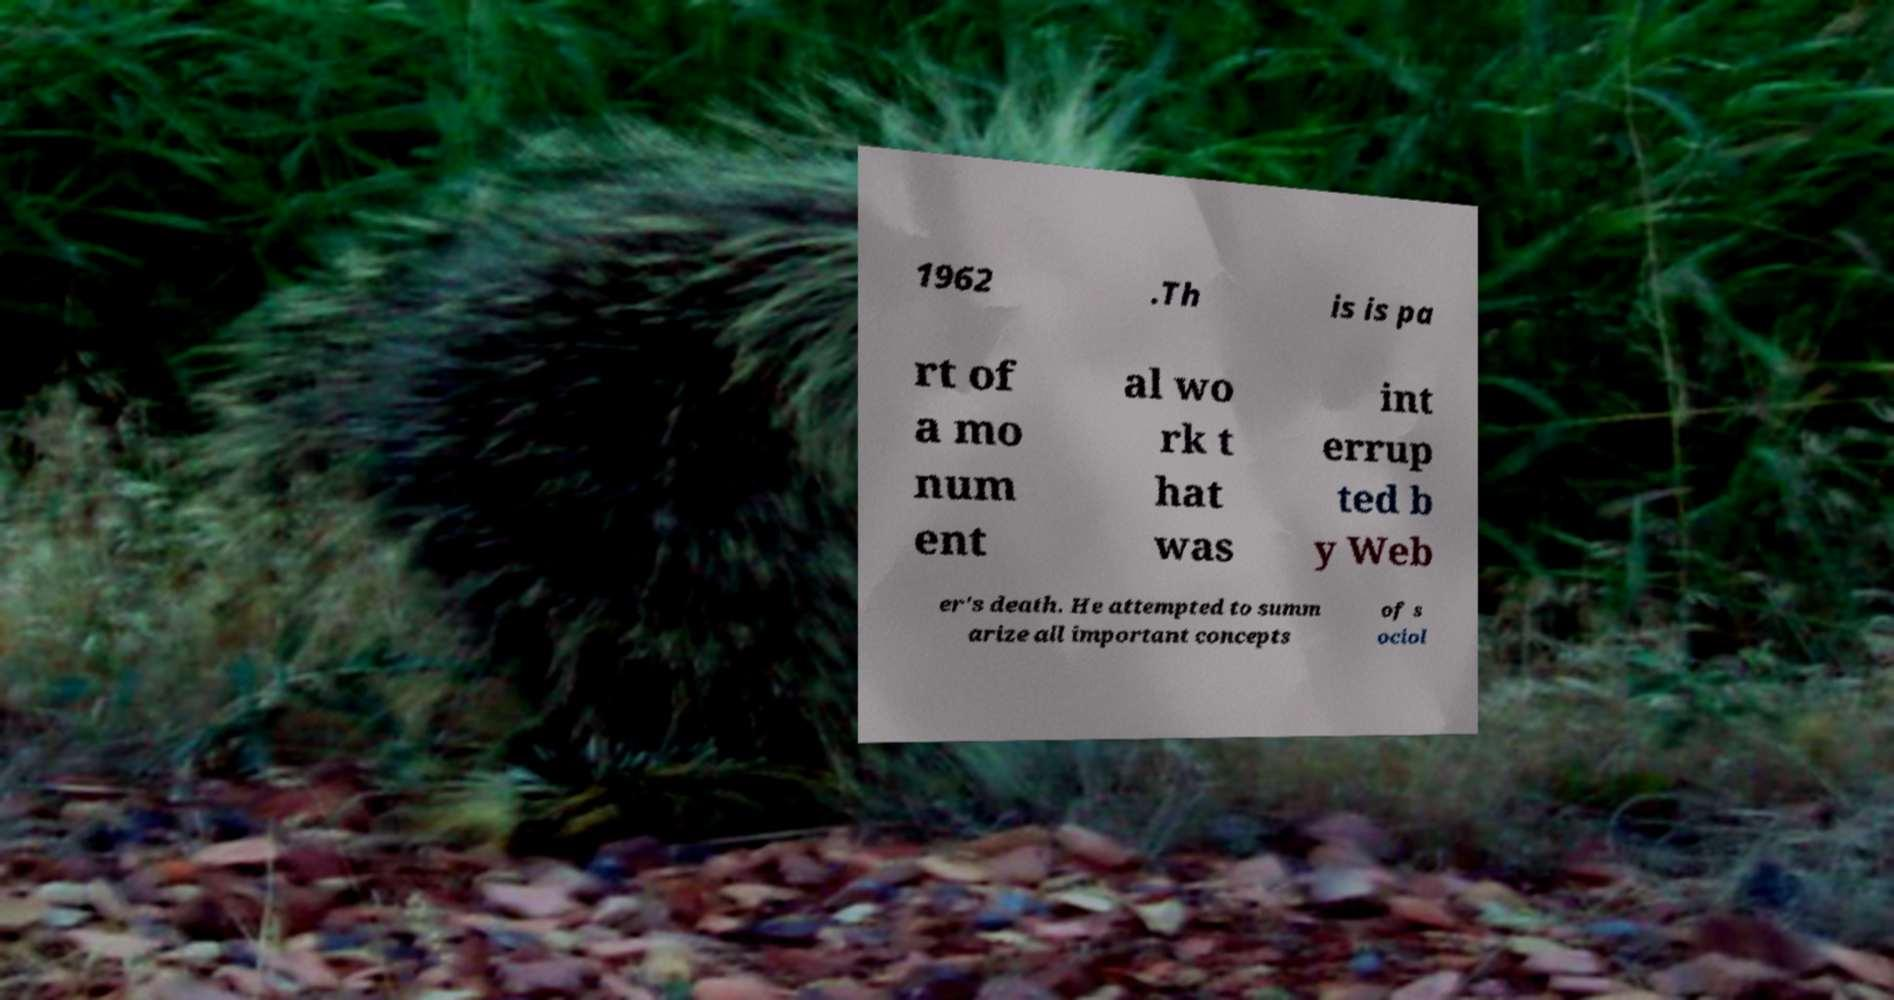For documentation purposes, I need the text within this image transcribed. Could you provide that? 1962 .Th is is pa rt of a mo num ent al wo rk t hat was int errup ted b y Web er's death. He attempted to summ arize all important concepts of s ociol 